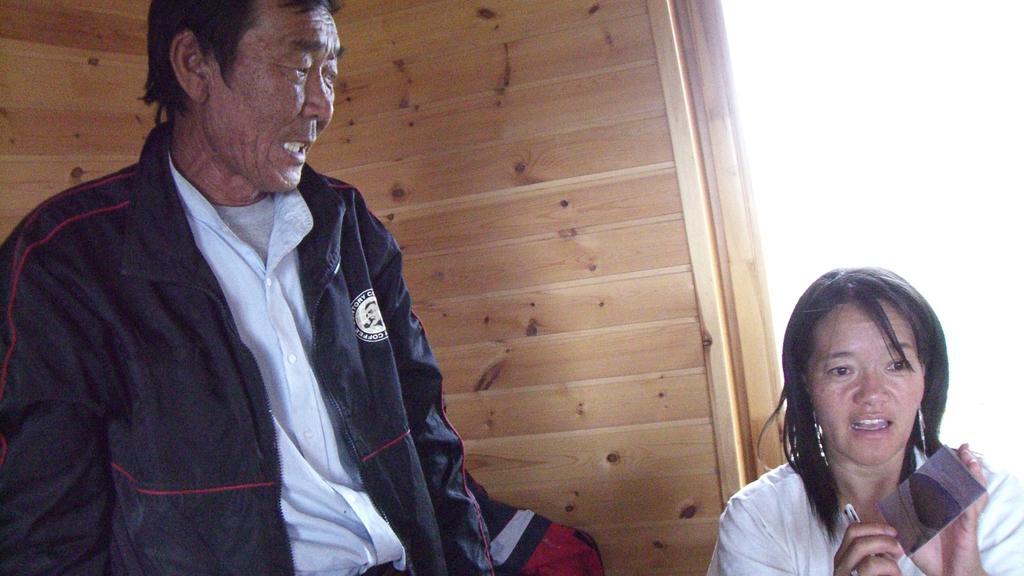Can you describe this image briefly? In this image there is a man standing, beside the man there is a woman holding some objects in her hand, behind them there is a wooden wall. 